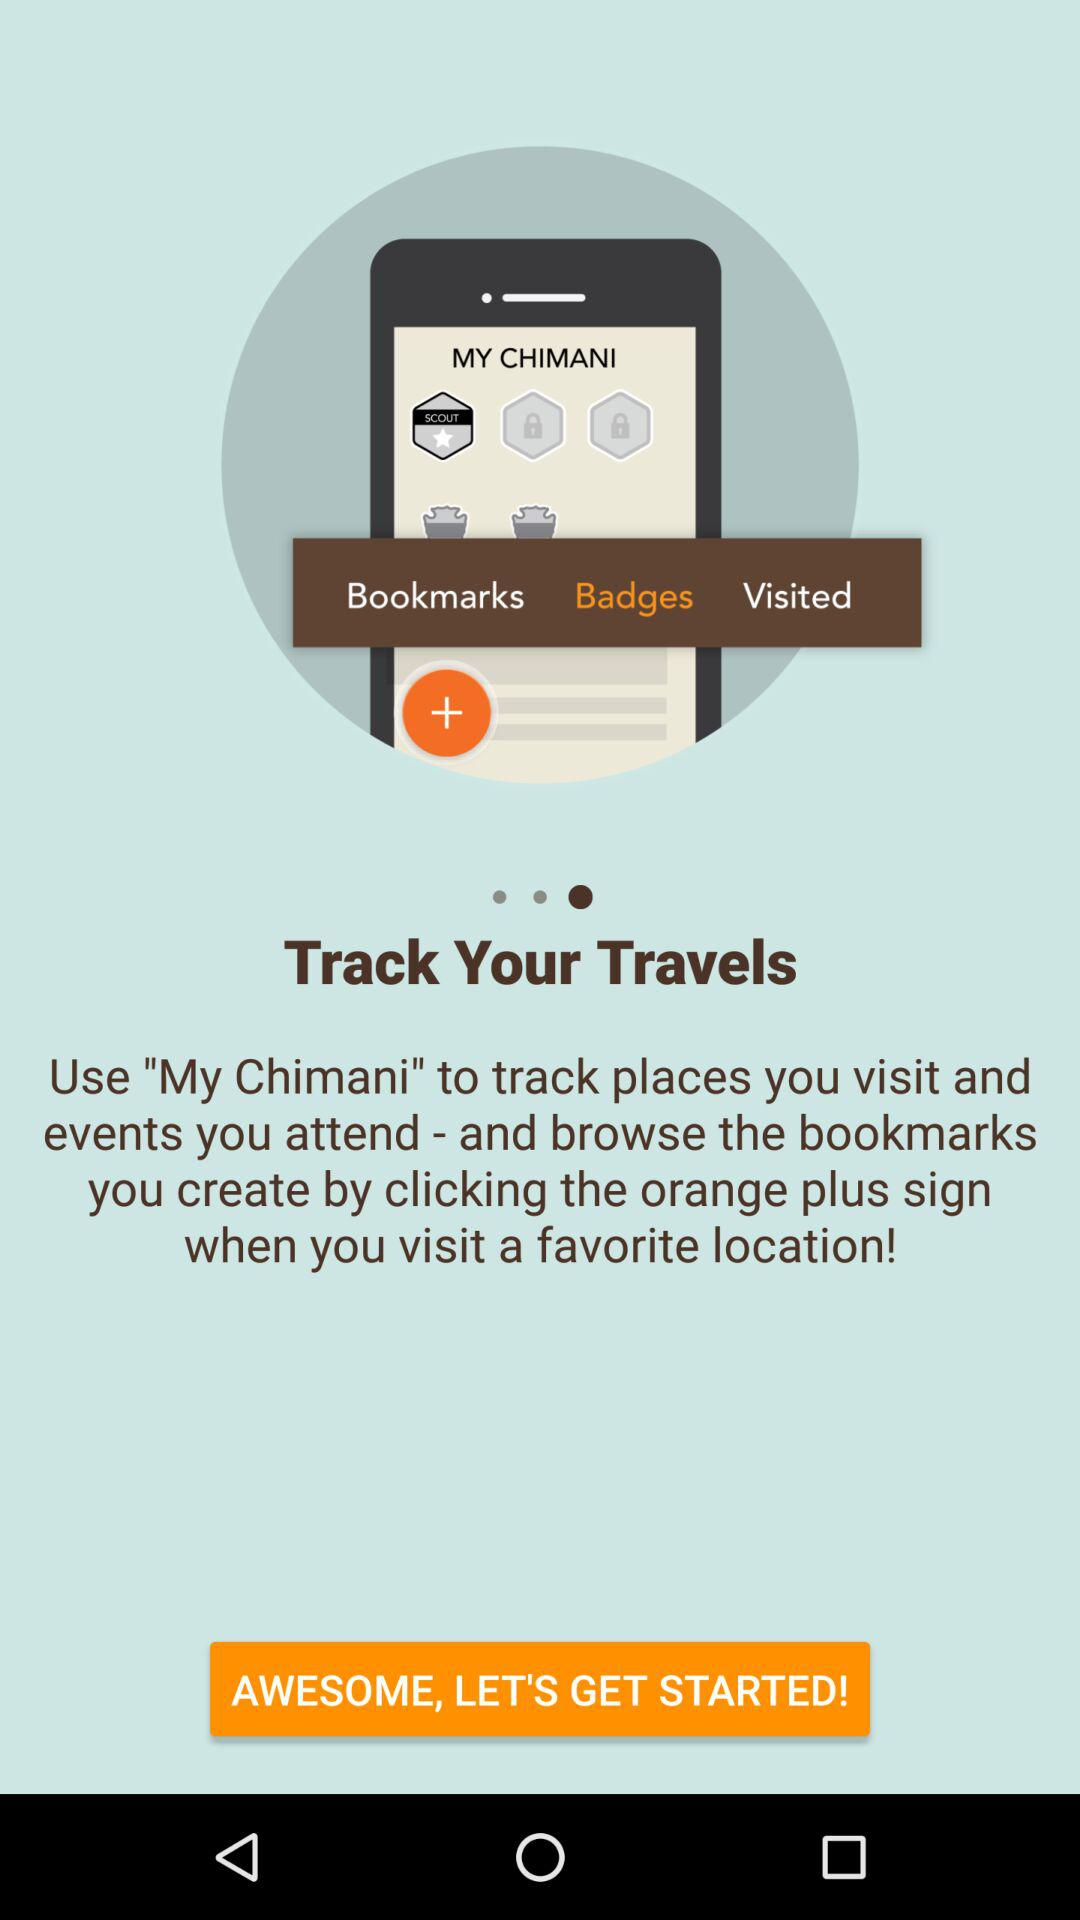What is the application name? The application name is "MY CHIMANI". 